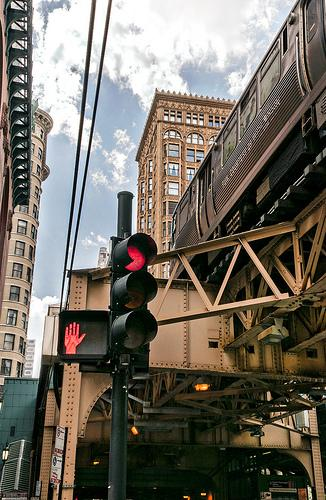What kind of building does the image show with lots of windows? The image shows a tall brown building with lots of windows. What color is the stop light in the image? The stop light is red. Give a brief summary of the weather conditions and the state of the sky in this image. It is a cloudy day in the image. Describe the object under the bridge and the lights around it. There is a tunnel under the bridge with various yellow and orange lights in it. Determine the shape and the color of the tall building located in the image. The tall building is rectangular in shape, and it is brown. Analyze the image and describe the overall sentiment or atmosphere it conveys. The image conveys a bustling urban atmosphere with various objects and modes of transportation, creating a sense of movement and activity. Can you count the number of traffic lights in the image? What is the total? There are two traffic lights in the image. Provide a short description of the scene captured in the image. An urban scene featuring multiple traffic lights, a tunnel, buildings with windows, telephone wires, a metro train crossing a bridge, and a cloudy sky. Identify the type of public transportation system visible in this picture and describe its location. A metro train is going by, crossing a bridge in the image. Please list the various types of objects that can be found in this picture, with no additional details. Traffic lights, tunnel, bridge, buildings, windows, metro train, telephone wires, cloudy sky. 